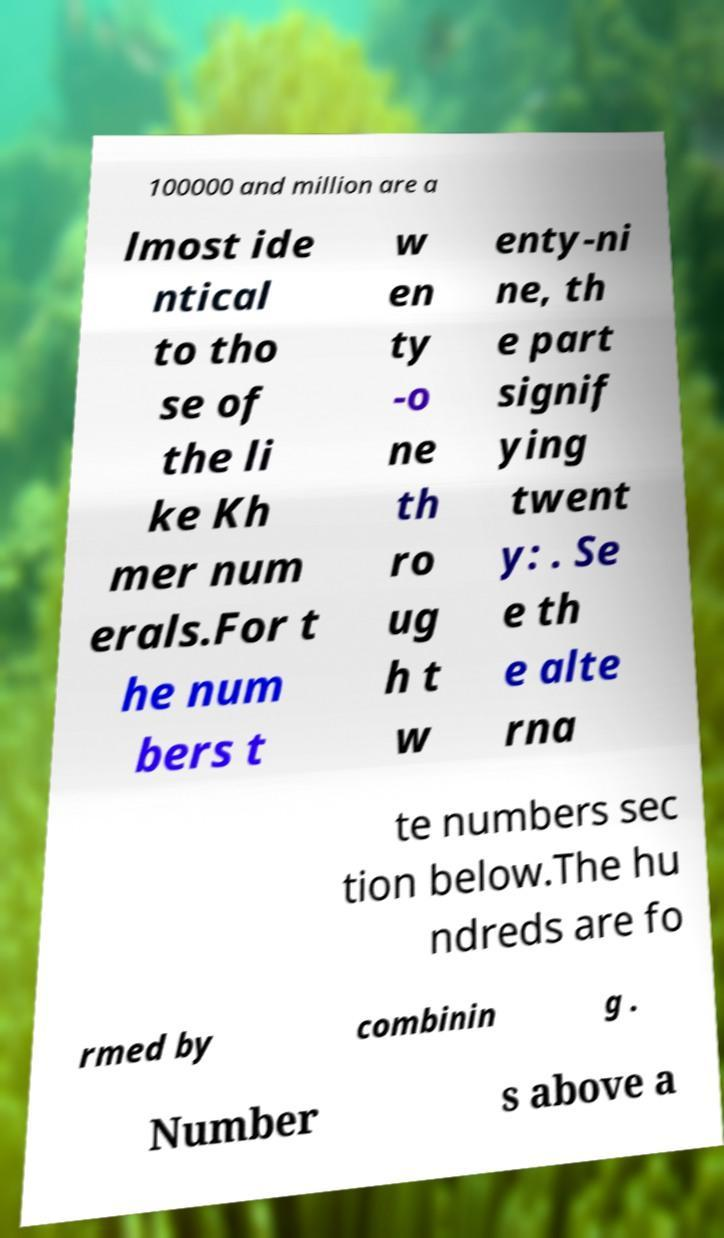Can you accurately transcribe the text from the provided image for me? 100000 and million are a lmost ide ntical to tho se of the li ke Kh mer num erals.For t he num bers t w en ty -o ne th ro ug h t w enty-ni ne, th e part signif ying twent y: . Se e th e alte rna te numbers sec tion below.The hu ndreds are fo rmed by combinin g . Number s above a 